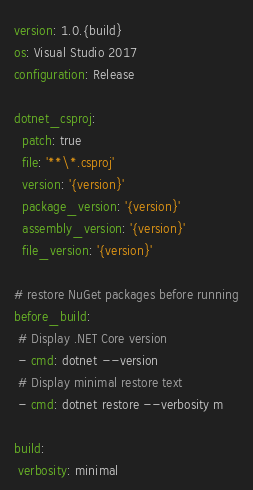<code> <loc_0><loc_0><loc_500><loc_500><_YAML_>version: 1.0.{build}
os: Visual Studio 2017
configuration: Release

dotnet_csproj:
  patch: true
  file: '**\*.csproj'
  version: '{version}'
  package_version: '{version}'
  assembly_version: '{version}'
  file_version: '{version}'

# restore NuGet packages before running
before_build:
 # Display .NET Core version
 - cmd: dotnet --version
 # Display minimal restore text
 - cmd: dotnet restore --verbosity m
  
build:
 verbosity: minimal
</code> 